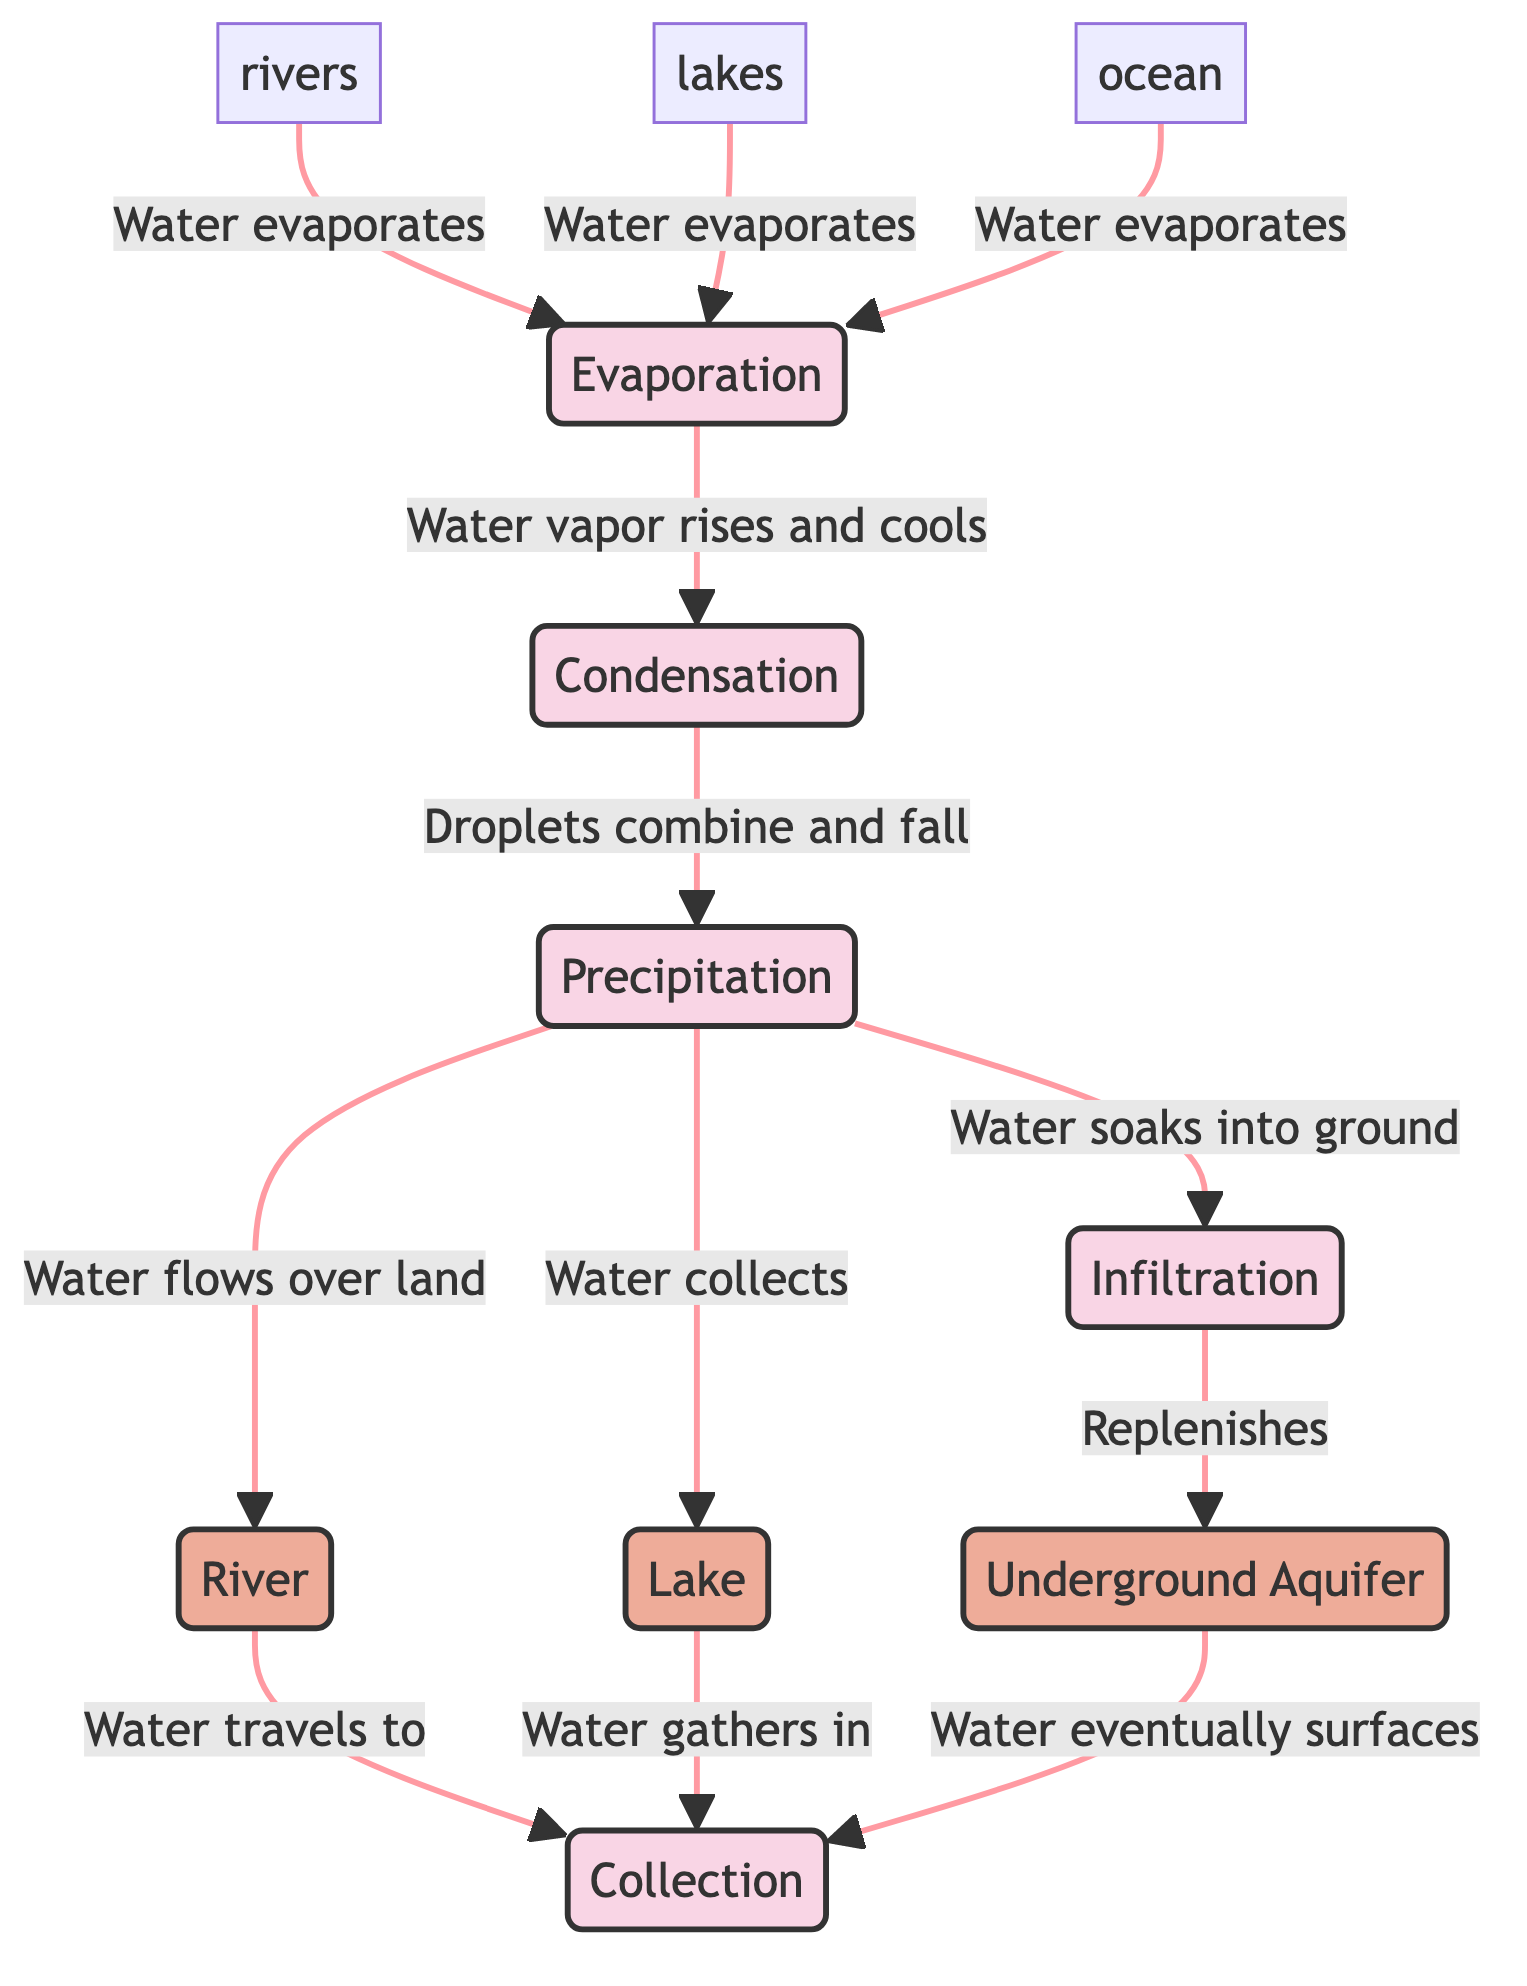What is the first process in the water cycle? The diagram begins with the process labeled "Evaporation," indicating it is the first step in the water cycle.
Answer: Evaporation How many processes are shown in the diagram? The diagram contains five distinct processes: Evaporation, Condensation, Precipitation, Infiltration, and Collection.
Answer: 5 What flows into a river after precipitation? The diagram indicates that precipitation results in water flowing over land, which contributes to the river.
Answer: Water What connects condensation to precipitation? The diagram shows that condensation leads to precipitation through the process where droplets combine and fall from condensation.
Answer: Droplets Which process replenishes underground aquifers? According to the diagram, infiltration is the process that soaks water into the ground and replenishes underground aquifers.
Answer: Infiltration What type of water bodies are associated with the collection process? The diagram indicates that both rivers and lakes are associated with the collection process, where water gathers.
Answer: Rivers and lakes How does water return to the surface from underground aquifers? The diagram illustrates that water eventually surfaces from underground aquifers to the collection stage.
Answer: Collection Which element does evaporation directly link to? The diagram shows that evaporation directly links to condensation, as water vapor rises and cools during this stage.
Answer: Condensation What happens to water after precipitation collects in a lake? The diagram shows that water in the lake will gather in the collection process, indicating its next stage in the cycle.
Answer: Gathers 